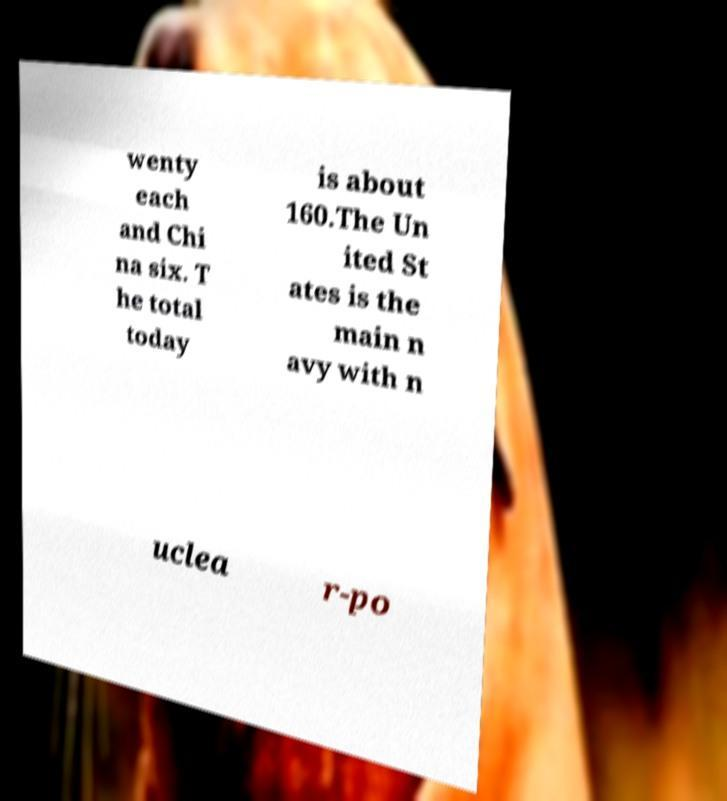Could you assist in decoding the text presented in this image and type it out clearly? wenty each and Chi na six. T he total today is about 160.The Un ited St ates is the main n avy with n uclea r-po 